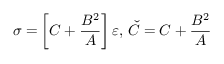Convert formula to latex. <formula><loc_0><loc_0><loc_500><loc_500>\, \sigma = \left [ C + \frac { B ^ { 2 } } { A } \right ] \varepsilon , \, \check { C } = C + \frac { B ^ { 2 } } { A }</formula> 